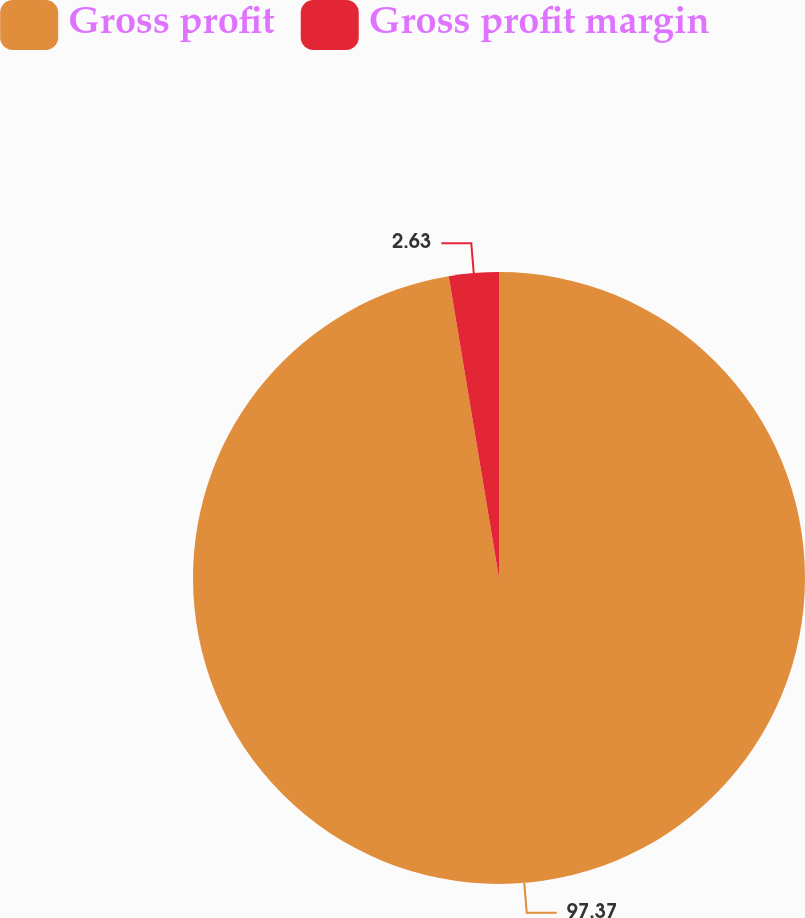<chart> <loc_0><loc_0><loc_500><loc_500><pie_chart><fcel>Gross profit<fcel>Gross profit margin<nl><fcel>97.37%<fcel>2.63%<nl></chart> 